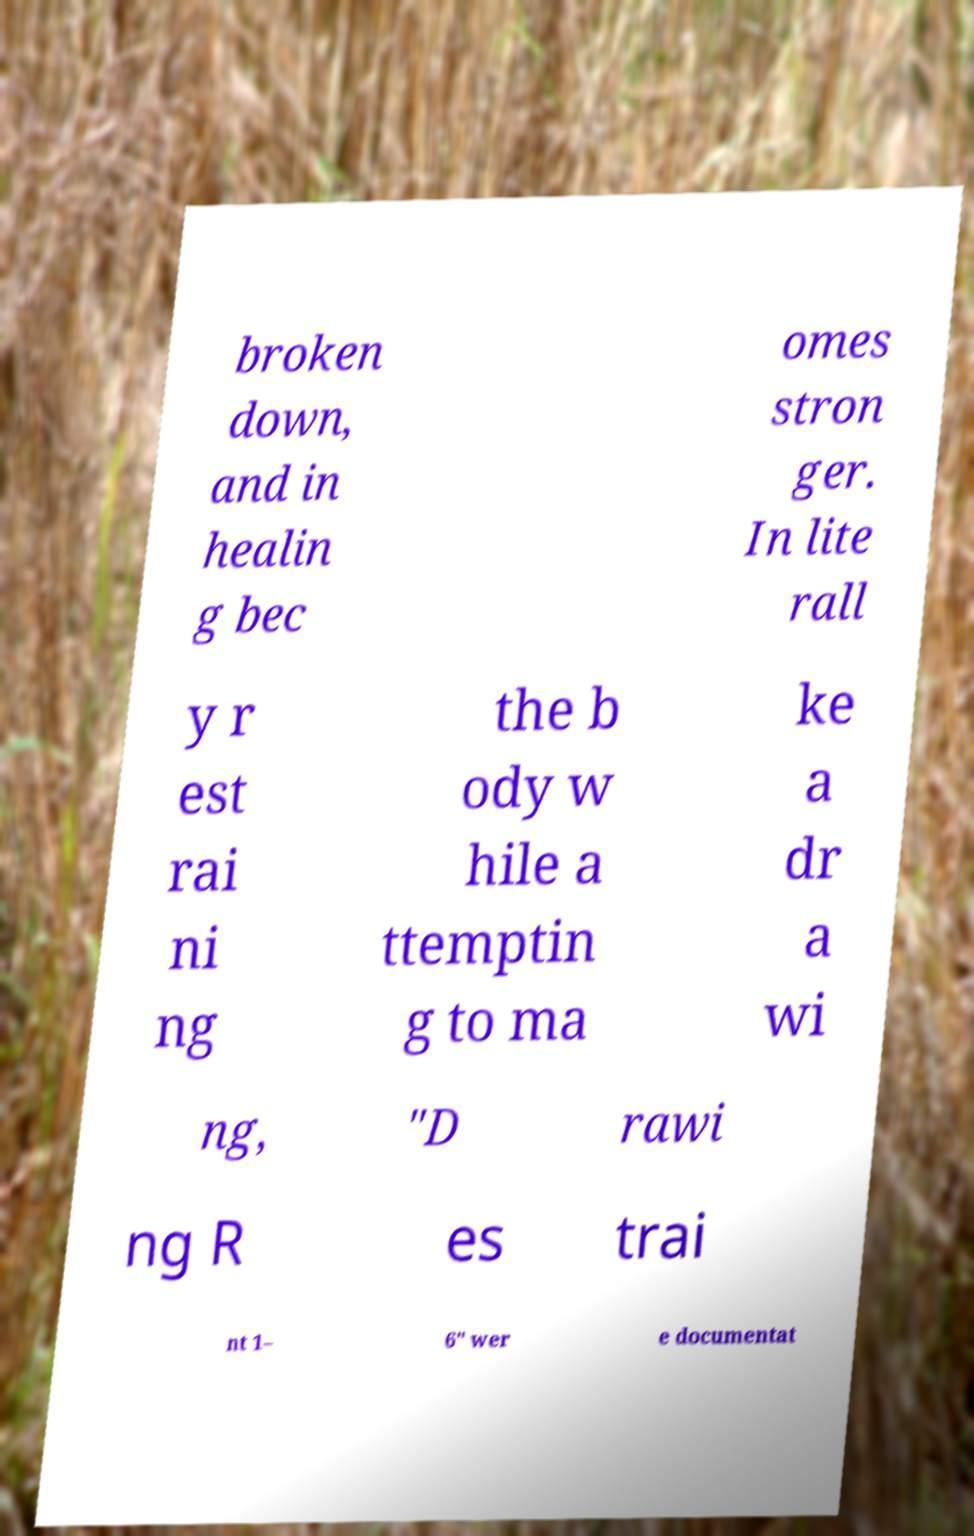Could you extract and type out the text from this image? broken down, and in healin g bec omes stron ger. In lite rall y r est rai ni ng the b ody w hile a ttemptin g to ma ke a dr a wi ng, "D rawi ng R es trai nt 1– 6" wer e documentat 